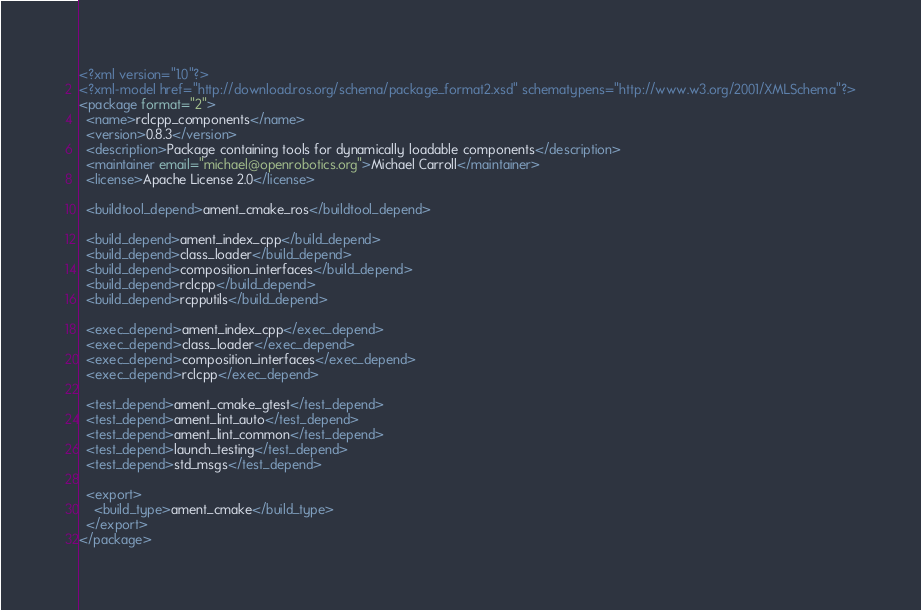Convert code to text. <code><loc_0><loc_0><loc_500><loc_500><_XML_><?xml version="1.0"?>
<?xml-model href="http://download.ros.org/schema/package_format2.xsd" schematypens="http://www.w3.org/2001/XMLSchema"?>
<package format="2">
  <name>rclcpp_components</name>
  <version>0.8.3</version>
  <description>Package containing tools for dynamically loadable components</description>
  <maintainer email="michael@openrobotics.org">Michael Carroll</maintainer>
  <license>Apache License 2.0</license>

  <buildtool_depend>ament_cmake_ros</buildtool_depend>

  <build_depend>ament_index_cpp</build_depend>
  <build_depend>class_loader</build_depend>
  <build_depend>composition_interfaces</build_depend>
  <build_depend>rclcpp</build_depend>
  <build_depend>rcpputils</build_depend>

  <exec_depend>ament_index_cpp</exec_depend>
  <exec_depend>class_loader</exec_depend>
  <exec_depend>composition_interfaces</exec_depend>
  <exec_depend>rclcpp</exec_depend>

  <test_depend>ament_cmake_gtest</test_depend>
  <test_depend>ament_lint_auto</test_depend>
  <test_depend>ament_lint_common</test_depend>
  <test_depend>launch_testing</test_depend>
  <test_depend>std_msgs</test_depend>

  <export>
    <build_type>ament_cmake</build_type>
  </export>
</package>

</code> 